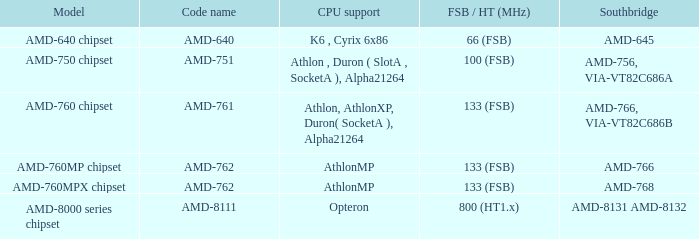What is the Southbridge when the CPU support was athlon, athlonxp, duron( socketa ), alpha21264? AMD-766, VIA-VT82C686B. 